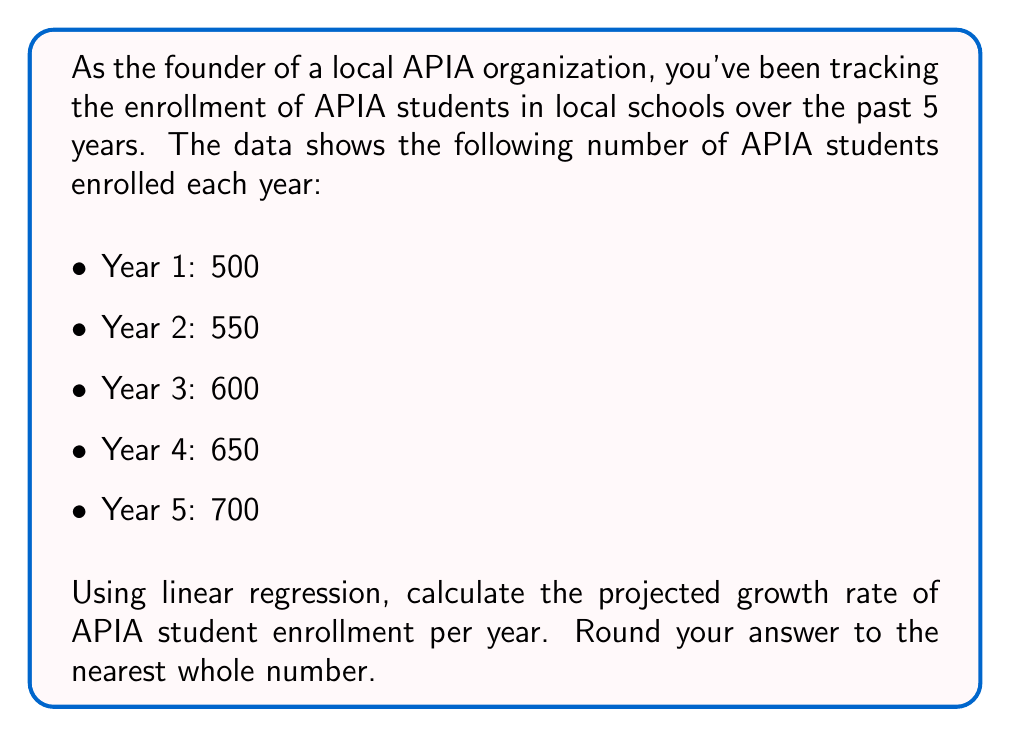Provide a solution to this math problem. To calculate the projected growth rate using linear regression, we'll follow these steps:

1) Let x represent the year (1 to 5) and y represent the number of APIA students.

2) Calculate the means of x and y:
   $\bar{x} = \frac{1 + 2 + 3 + 4 + 5}{5} = 3$
   $\bar{y} = \frac{500 + 550 + 600 + 650 + 700}{5} = 600$

3) Calculate $\sum(x - \bar{x})(y - \bar{y})$ and $\sum(x - \bar{x})^2$:

   $$\begin{array}{c|c|c|c|c}
   x & y & x - \bar{x} & y - \bar{y} & (x - \bar{x})(y - \bar{y}) & (x - \bar{x})^2 \\
   \hline
   1 & 500 & -2 & -100 & 200 & 4 \\
   2 & 550 & -1 & -50 & 50 & 1 \\
   3 & 600 & 0 & 0 & 0 & 0 \\
   4 & 650 & 1 & 50 & 50 & 1 \\
   5 & 700 & 2 & 100 & 200 & 4 \\
   \hline
   & & & \sum = 500 & \sum = 10
   \end{array}$$

4) Calculate the slope (m) of the regression line:
   $$m = \frac{\sum(x - \bar{x})(y - \bar{y})}{\sum(x - \bar{x})^2} = \frac{500}{10} = 50$$

5) The slope represents the average increase in APIA student enrollment per year.

6) Round to the nearest whole number: 50.

Therefore, the projected growth rate of APIA student enrollment is 50 students per year.
Answer: 50 students per year 